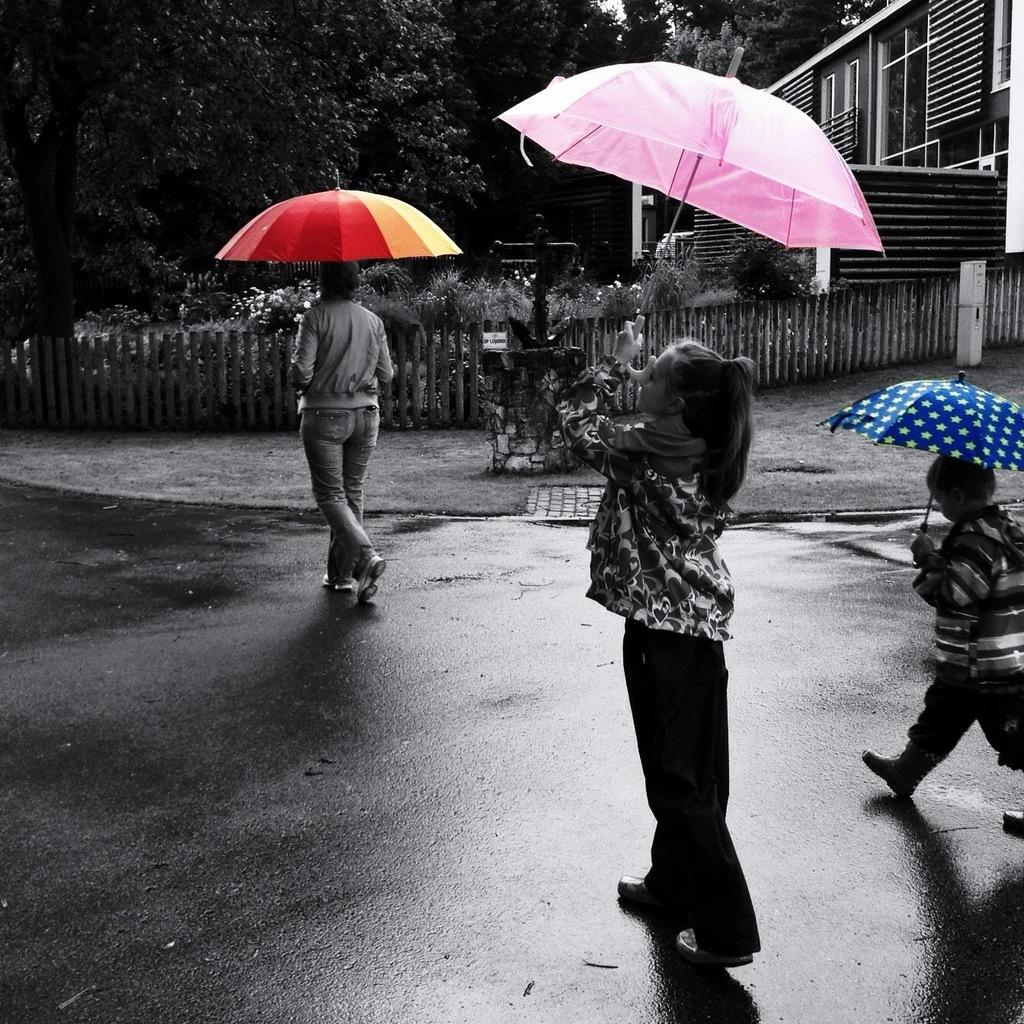How many people are present in the image? There are three people in the image. What are the people holding in the image? The three people are holding umbrellas. What can be seen in the background of the image? There is a fence, a building, plants, and trees in the background of the image. What color of paint is being used by the person on the left to start unlocking the door in the image? There is no person on the left using paint to unlock a door in the image. 